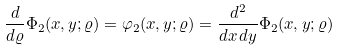Convert formula to latex. <formula><loc_0><loc_0><loc_500><loc_500>\frac { d } { d \varrho } \Phi _ { 2 } ( x , y ; \varrho ) = \varphi _ { 2 } ( x , y ; \varrho ) = \frac { d ^ { 2 } } { d x \, d y } \Phi _ { 2 } ( x , y ; \varrho )</formula> 